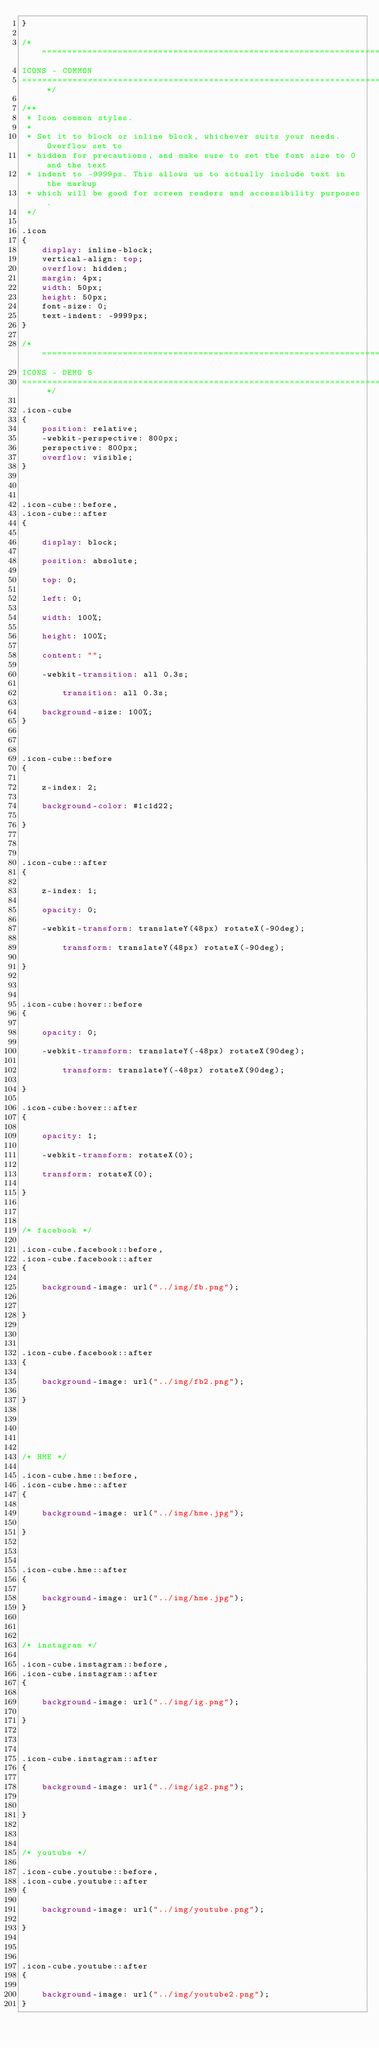Convert code to text. <code><loc_0><loc_0><loc_500><loc_500><_CSS_>}

/* =============================================================================
ICONS - COMMON
============================================================================= */

/**
 * Icon common styles.
 *
 * Set it to block or inline block, whichever suits your needs. Overflow set to
 * hidden for precautions, and make sure to set the font size to 0 and the text
 * indent to -9999px. This allows us to actually include text in the markup
 * which will be good for screen readers and accessibility purposes.
 */

.icon
{
	display: inline-block;
	vertical-align: top;
	overflow: hidden;
	margin: 4px;
	width: 50px;
	height: 50px;
	font-size: 0;
	text-indent: -9999px;
}

/* =============================================================================
ICONS - DEMO 5
============================================================================= */

.icon-cube
{
	position: relative;
	-webkit-perspective: 800px;
  	perspective: 800px;
	overflow: visible;
}



.icon-cube::before,
.icon-cube::after
{

	display: block;

 	position: absolute;

 	top: 0;

	left: 0;

 	width: 100%;

	height: 100%;

 	content: "";

 	-webkit-transition: all 0.3s;

    	transition: all 0.3s;

	background-size: 100%;
}



.icon-cube::before
{

	z-index: 2;

 	background-color: #1c1d22;

}



.icon-cube::after
{

	z-index: 1;

	opacity: 0;

	-webkit-transform: translateY(48px) rotateX(-90deg);

     	transform: translateY(48px) rotateX(-90deg);

}



.icon-cube:hover::before
{

	opacity: 0;

	-webkit-transform: translateY(-48px) rotateX(90deg);

     	transform: translateY(-48px) rotateX(90deg);

}

.icon-cube:hover::after
{

 	opacity: 1;

	-webkit-transform: rotateX(0);

  	transform: rotateX(0);

}



/* facebook */

.icon-cube.facebook::before,
.icon-cube.facebook::after
{

	background-image: url("../img/fb.png");


}



.icon-cube.facebook::after
{

	background-image: url("../img/fb2.png");

}





/* HME */

.icon-cube.hme::before,
.icon-cube.hme::after
{

	background-image: url("../img/hme.jpg");

}



.icon-cube.hme::after
{

	background-image: url("../img/hme.jpg");
}



/* instagram */

.icon-cube.instagram::before,
.icon-cube.instagram::after
{

	background-image: url("../img/ig.png");

}



.icon-cube.instagram::after
{

	background-image: url("../img/ig2.png");


}



/* youtube */

.icon-cube.youtube::before,
.icon-cube.youtube::after
{

	background-image: url("../img/youtube.png");

}



.icon-cube.youtube::after
{

	background-image: url("../img/youtube2.png");
}
</code> 